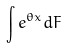Convert formula to latex. <formula><loc_0><loc_0><loc_500><loc_500>\int e ^ { \theta x } d F</formula> 